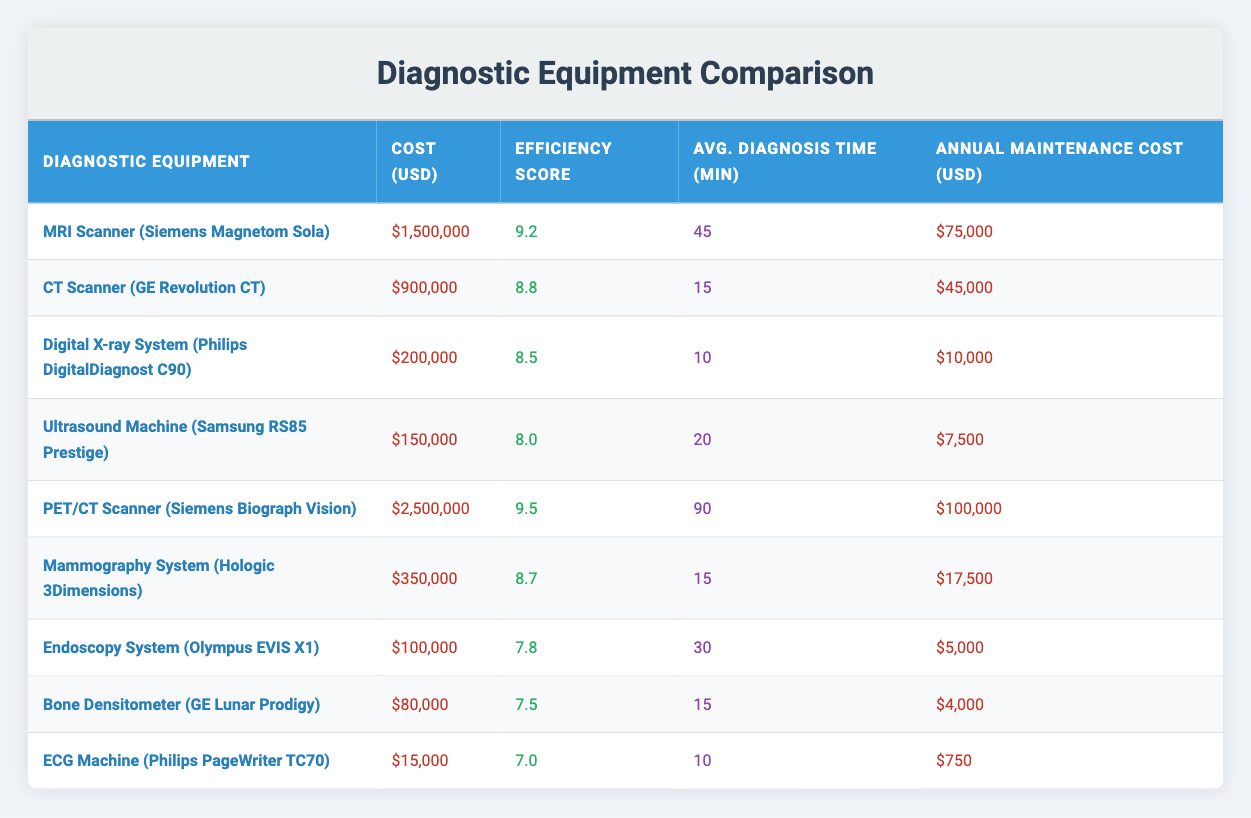What is the cost of the PET/CT Scanner? The cost of the PET/CT Scanner (Siemens Biograph Vision) is displayed in the corresponding row under the "Cost (USD)" column. It shows $2,500,000.
Answer: 2,500,000 Which equipment has the highest efficiency score? By examining the "Efficiency Score" column, it is clear that the PET/CT Scanner (Siemens Biograph Vision) has the highest score of 9.5.
Answer: PET/CT Scanner (Siemens Biograph Vision) What is the average diagnosis time for the Digital X-ray System and the Ultrasound Machine? The average diagnosis time can be calculated by adding the average times for both pieces of equipment: Digital X-ray System (10 minutes) and Ultrasound Machine (20 minutes). The total is 10 + 20 = 30 minutes. Dividing by 2 gives an average of 15 minutes.
Answer: 15 minutes Is the annual maintenance cost for the Bone Densitometer lower than that of the ECG Machine? The annual maintenance cost for the Bone Densitometer is $4,000 while the cost for the ECG Machine is $750. Since $4,000 is greater than $750, the statement is false.
Answer: No What is the difference in cost between the MRI Scanner and the CT Scanner? The cost of the MRI Scanner is $1,500,000 and the cost of the CT Scanner is $900,000. The difference can be found by subtracting the CT Scanner's cost from the MRI Scanner's: 1,500,000 - 900,000 = 600,000.
Answer: 600,000 How many pieces of equipment have an efficiency score of 8.0 or higher? By reviewing the efficiency scores for each piece of equipment, we find MRI Scanner (9.2), CT Scanner (8.8), Digital X-ray System (8.5), Ultrasound Machine (8.0), PET/CT Scanner (9.5), and Mammography System (8.7). This results in a total of 6 pieces of equipment.
Answer: 6 What is the maintenance cost for the equipment with the longest average diagnosis time? The equipment with the longest average diagnosis time is the PET/CT Scanner (90 minutes). The corresponding annual maintenance cost for this equipment is $100,000, as shown in the relevant row.
Answer: 100,000 Is the efficiency score of the Endoscopy System higher than that of the Mammography System? The efficiency score for the Endoscopy System (7.8) is compared to that of the Mammography System (8.7). Since 7.8 is less than 8.7, the statement is false.
Answer: No 